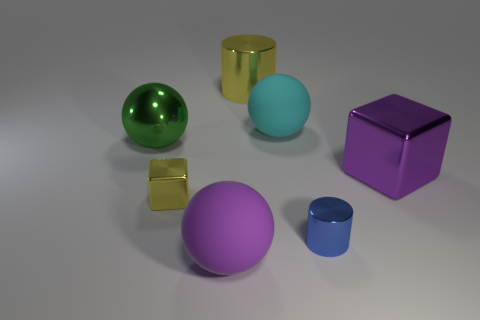Can you describe the lighting in the scene? The lighting in the scene provides a soft and diffuse illumination with subtle shadows, indicating an indirect light source that creates a calm and evenly lit composition. 